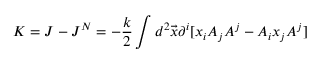Convert formula to latex. <formula><loc_0><loc_0><loc_500><loc_500>K = J - J ^ { N } = - \frac { k } { 2 } \int d ^ { 2 } \vec { x } \partial ^ { i } [ x _ { i } A _ { j } A ^ { j } - A _ { i } x _ { j } A ^ { j } ]</formula> 